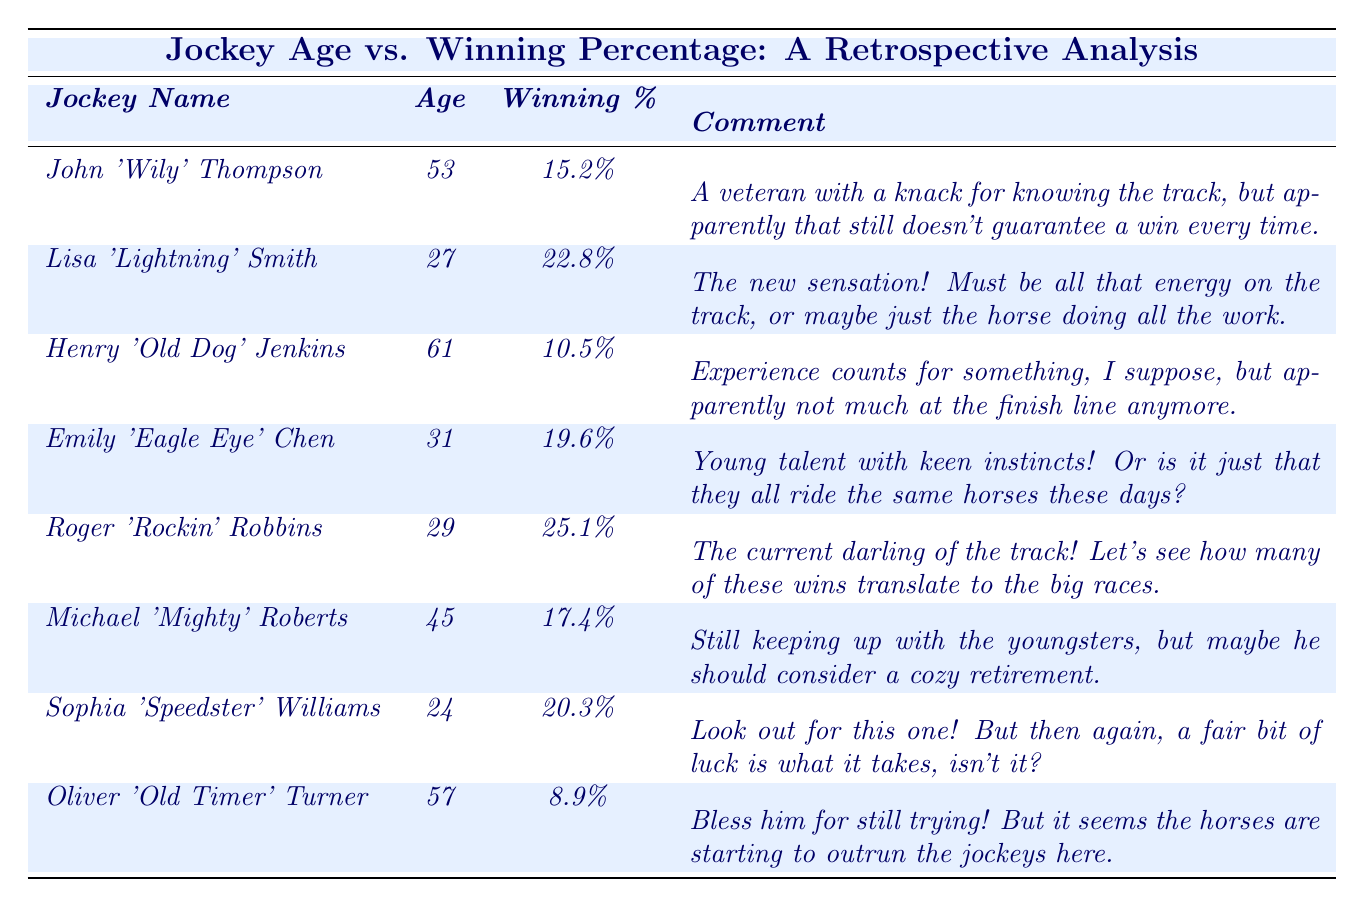What's the winning percentage of Roger 'Rockin' Robbins? The table shows that Roger 'Rockin' Robbins has a winning percentage of 25.1%.
Answer: 25.1% Which jockey is the oldest in the table? The table lists Henry 'Old Dog' Jenkins as the oldest jockey at 61 years of age.
Answer: Henry 'Old Dog' Jenkins What is the average winning percentage of all the jockeys listed? To find the average, sum the winning percentages: (15.2 + 22.8 + 10.5 + 19.6 + 25.1 + 17.4 + 20.3 + 8.9) = 119.8. Then, divide by the number of jockeys (8): 119.8 / 8 = 14.975.
Answer: 14.975% Is Lisa 'Lightning' Smith younger than Michael 'Mighty' Roberts? Lisa 'Lightning' Smith is 27 years old, while Michael 'Mighty' Roberts is 45 years old, so yes, she is younger.
Answer: Yes What is the difference in winning percentage between the youngest and oldest jockeys? The youngest jockey, Sophia 'Speedster' Williams, has a winning percentage of 20.3%, and the oldest, Henry 'Old Dog' Jenkins, has 10.5%. The difference is: 20.3% - 10.5% = 9.8%.
Answer: 9.8% Which jockey has the highest winning percentage? Upon inspection of the table, Roger 'Rockin' Robbins holds the highest winning percentage of 25.1%.
Answer: Roger 'Rockin' Robbins How many jockeys are over the age of 50? Referring to the table, the jockeys over 50 years old are Henry 'Old Dog' Jenkins (61) and Oliver 'Old Timer' Turner (57), totaling 2.
Answer: 2 What percentage of jockeys have a winning percentage higher than 20%? The table shows Roger 'Rockin' Robbins (25.1%), Lisa 'Lightning' Smith (22.8%), and Sophia 'Speedster' Williams (20.3%), so that’s 3 out of 8 jockeys, calculated as (3/8) * 100 = 37.5%.
Answer: 37.5% 